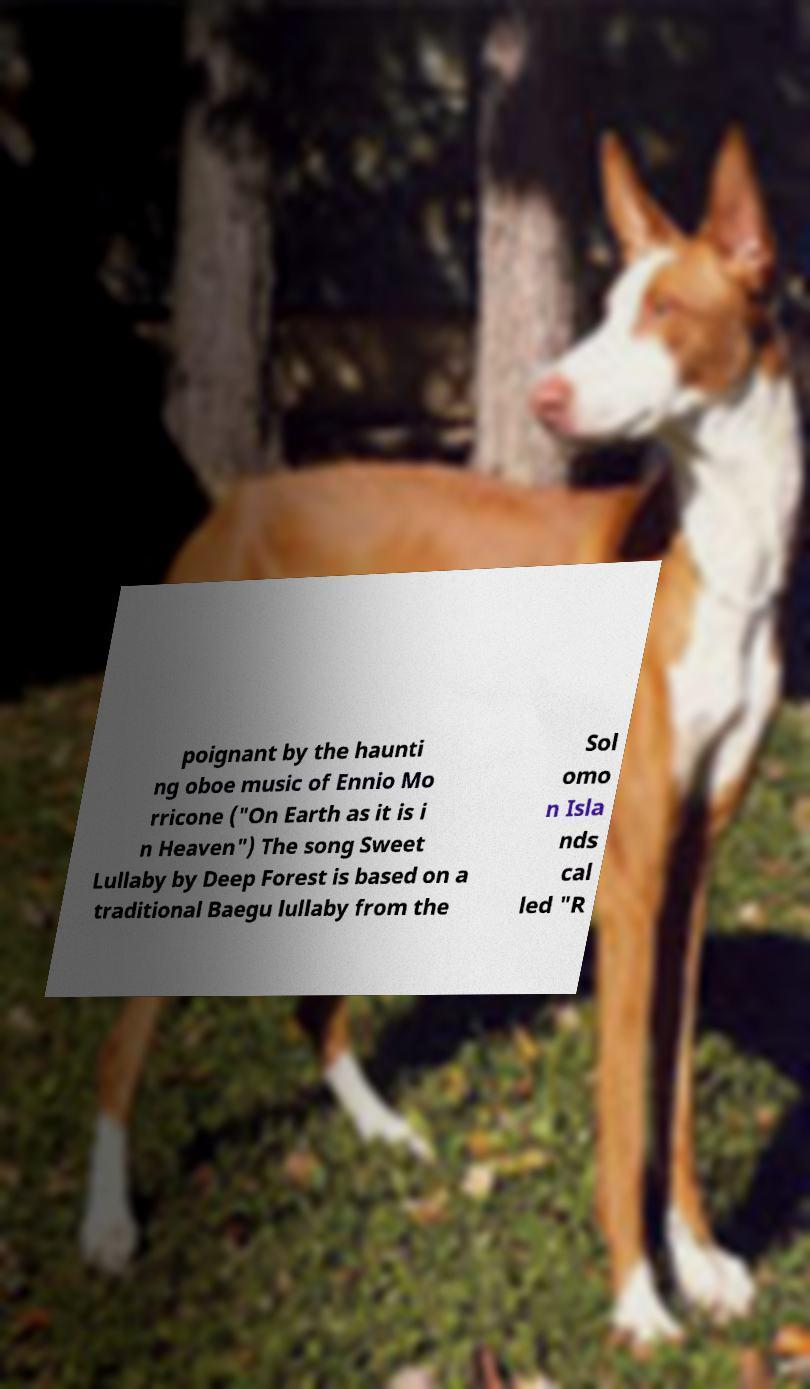Please read and relay the text visible in this image. What does it say? poignant by the haunti ng oboe music of Ennio Mo rricone ("On Earth as it is i n Heaven") The song Sweet Lullaby by Deep Forest is based on a traditional Baegu lullaby from the Sol omo n Isla nds cal led "R 